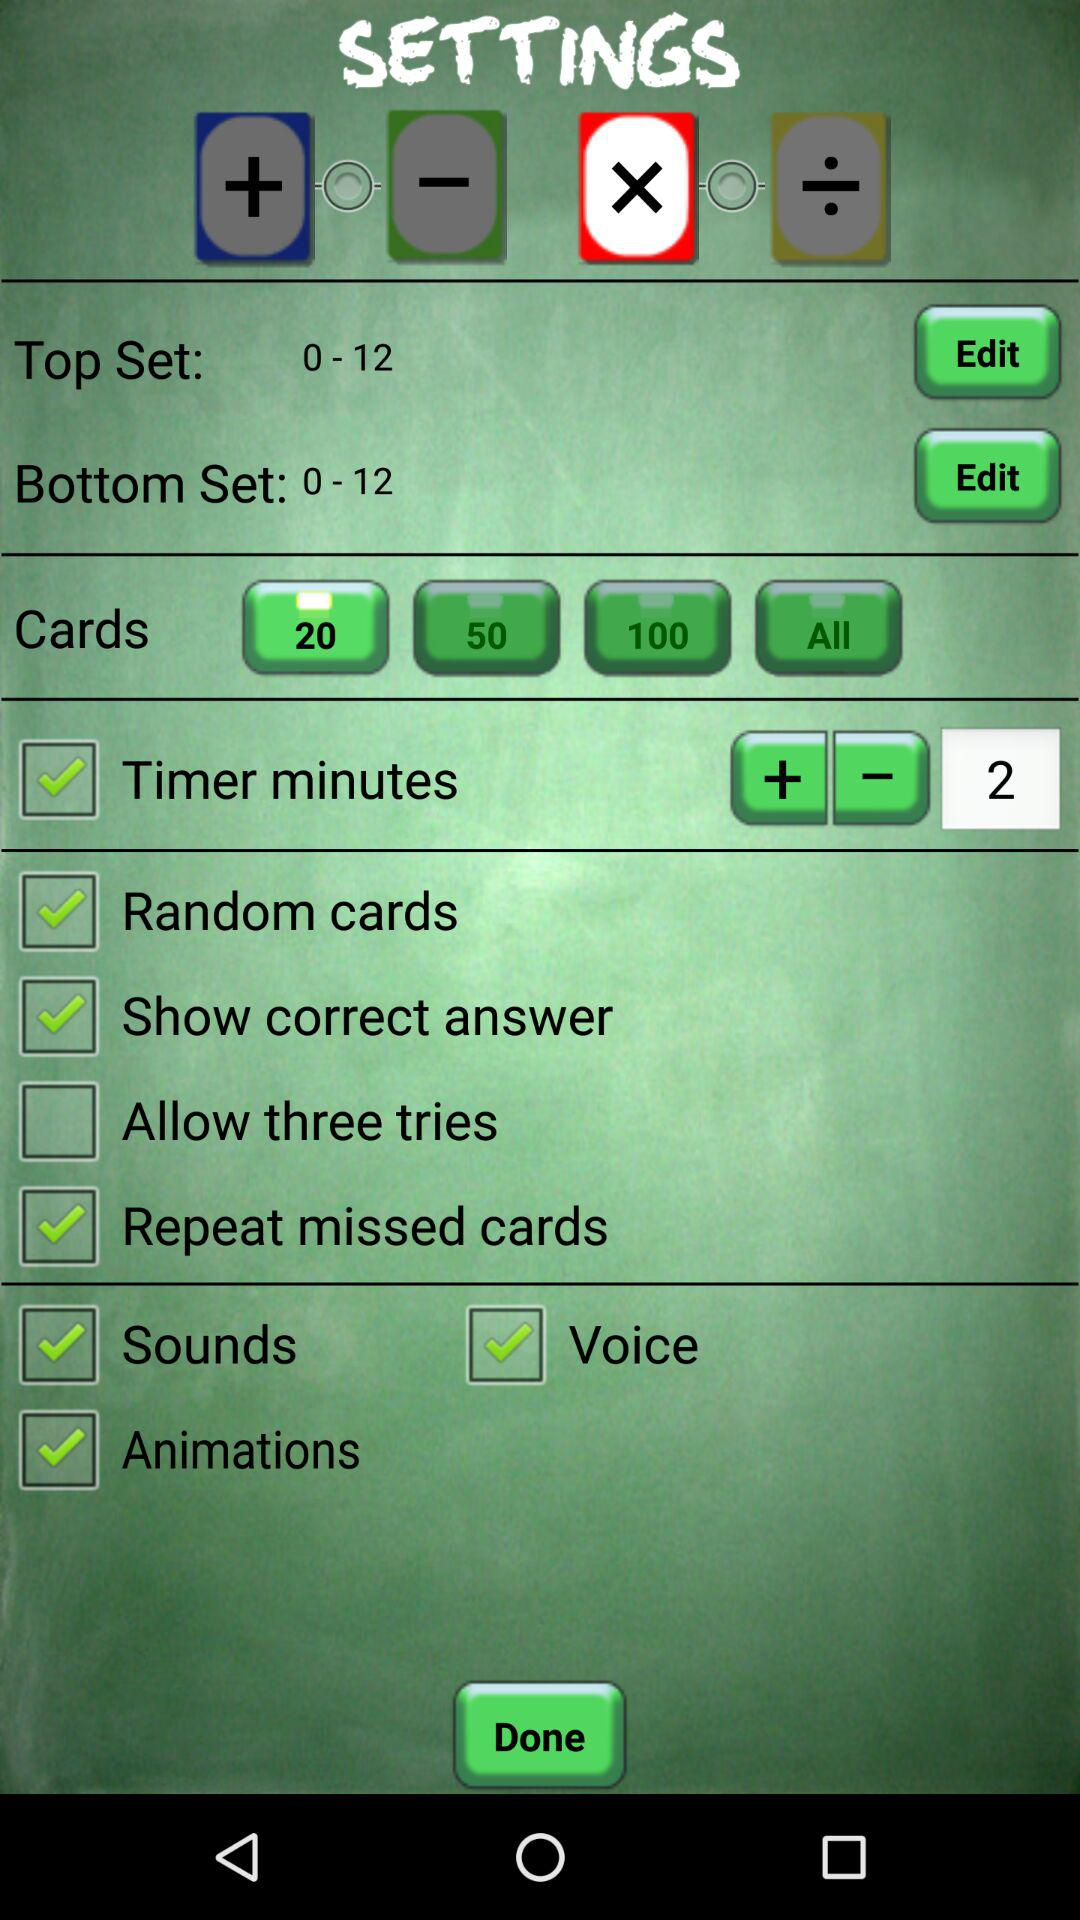What option is not marked as checked? The option that is not marked as checked is "Allow three tries". 